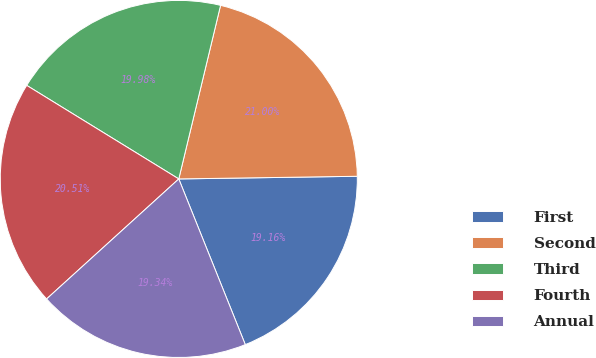Convert chart. <chart><loc_0><loc_0><loc_500><loc_500><pie_chart><fcel>First<fcel>Second<fcel>Third<fcel>Fourth<fcel>Annual<nl><fcel>19.16%<fcel>21.0%<fcel>19.98%<fcel>20.51%<fcel>19.34%<nl></chart> 